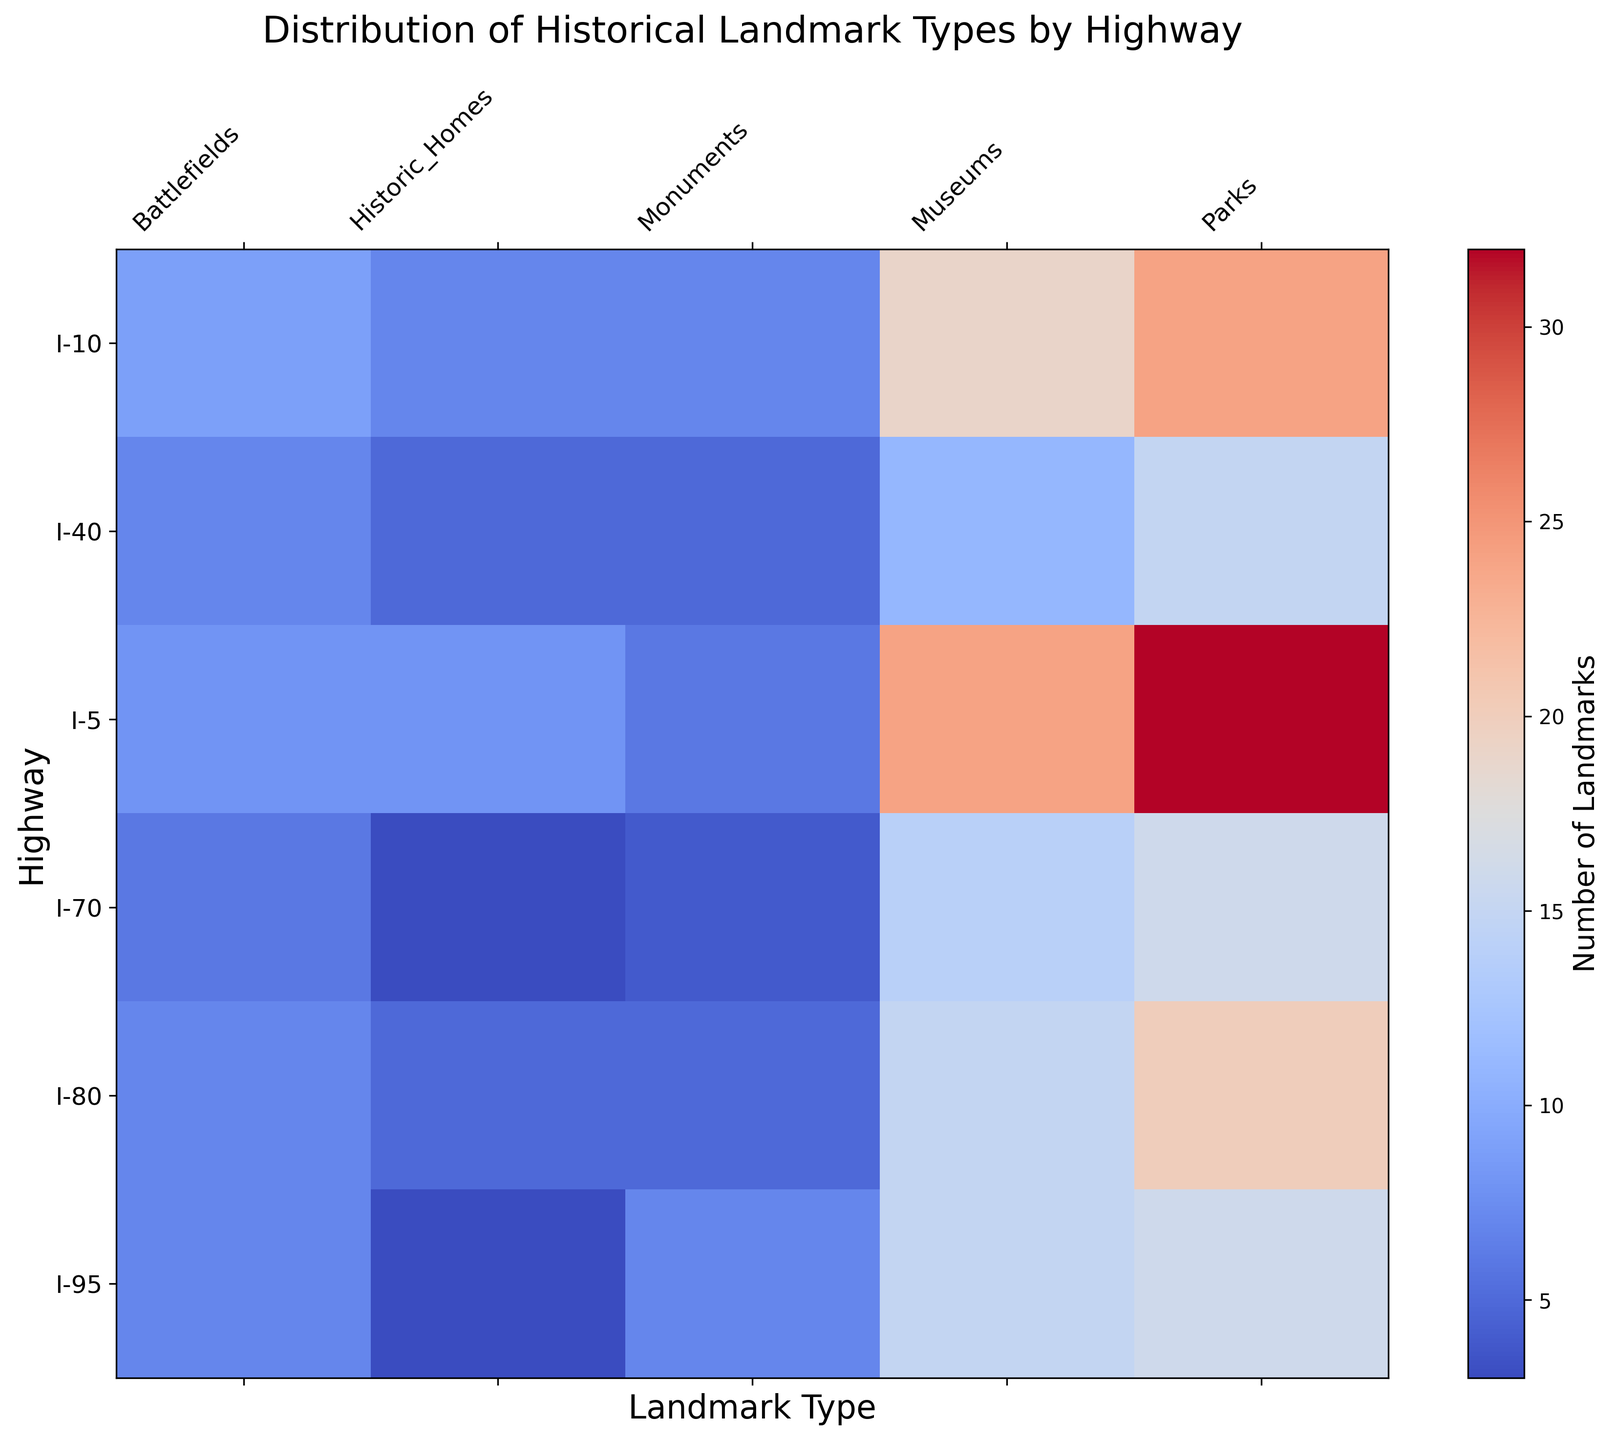What's the highway with the highest number of landmarks in a single category? By looking at the figure, observe the brightest or most intense colors in any column to find the highest value. I-5 in California has the most with 20 Parks.
Answer: I-5 Which landmark type has the most uniform distribution across all highways? Analyze the heatmap for the category where the color intensity varies the least across all highways. Monuments appear to have the most uniform distribution.
Answer: Monuments Which highway has a higher average number of landmarks across all types, I-95 or I-10? Calculate the average number of landmarks for each type by summing all the values and dividing by the number of types. For I-95 (VA + MD): (5+2+8+7+3+4+10+6+2+1)/5 = 48/5 = 9.6. For I-10 (TX + LA): (6+3+12+7+5+2+15+9+4+3)/5 = 66/5 = 13.2.
Answer: I-10 Which state along I-80 has more historic homes, Pennsylvania or Ohio? Look at the color intensity corresponding to the 'Historic_Homes' column for PA and OH under I-80. Ohio has a slightly higher value with 3 compared to Pennsylvania's 2.
Answer: Ohio Does any highway have an equal number of museums and battlefields? Compare each highway's values for Museums and Battlefields by observing the color intensity for these two categories. I-70 (KS) has 5 Museums and 2 Battlefields, not equal. I-10 (LA) has 7 Museums and 3 Battlefields, not equal. No highways have equal numbers.
Answer: No What's the total number of landmarks (all types combined) along I-40? Sum the values for all landmark types in I-40 (NC + TN). For TN: 3+5+2+7+3 = 20. For NC: 4+6+3+8+2 = 23. Total is 20 + 23 = 43.
Answer: 43 Which category shows the highest contrast in color intensity for I-5 compared to other highways? Observe which category for I-5 stands out the most in terms of brightness compared to the same category for other highways. 'Parks' show the most contrast with I-5 being significantly higher than all others.
Answer: Parks Are there more battlefields in Texas or North Carolina? Compare the values in the 'Battlefields' column for Texas and North Carolina from the heatmap. Texas has 6 and North Carolina has 4.
Answer: Texas 